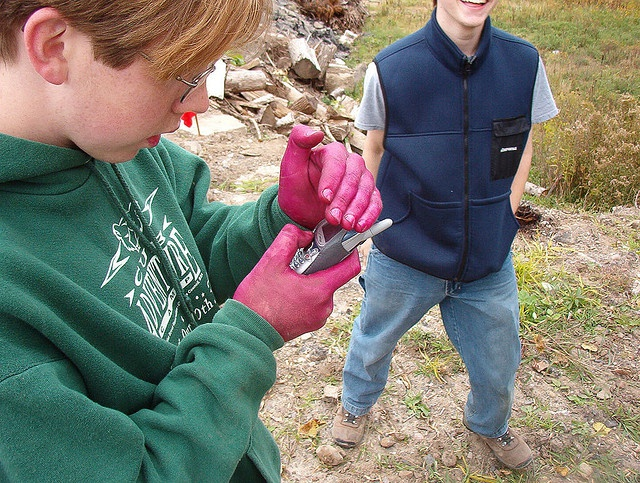Describe the objects in this image and their specific colors. I can see people in black, teal, lightpink, and brown tones, people in black, navy, gray, and blue tones, and cell phone in black, gray, darkgray, lightgray, and maroon tones in this image. 